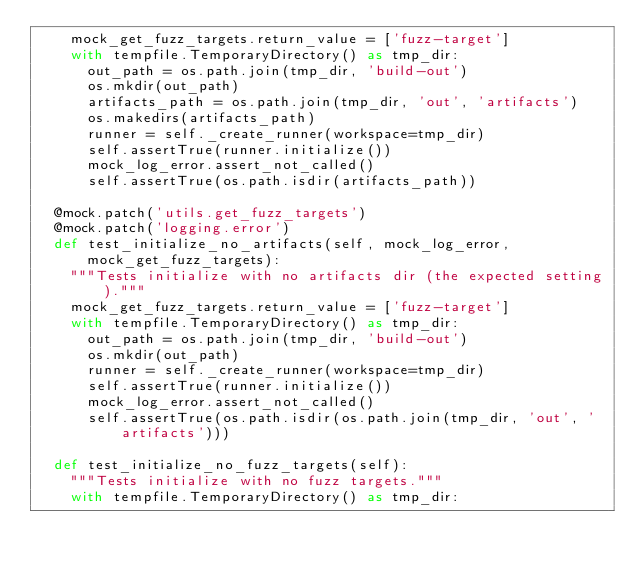Convert code to text. <code><loc_0><loc_0><loc_500><loc_500><_Python_>    mock_get_fuzz_targets.return_value = ['fuzz-target']
    with tempfile.TemporaryDirectory() as tmp_dir:
      out_path = os.path.join(tmp_dir, 'build-out')
      os.mkdir(out_path)
      artifacts_path = os.path.join(tmp_dir, 'out', 'artifacts')
      os.makedirs(artifacts_path)
      runner = self._create_runner(workspace=tmp_dir)
      self.assertTrue(runner.initialize())
      mock_log_error.assert_not_called()
      self.assertTrue(os.path.isdir(artifacts_path))

  @mock.patch('utils.get_fuzz_targets')
  @mock.patch('logging.error')
  def test_initialize_no_artifacts(self, mock_log_error, mock_get_fuzz_targets):
    """Tests initialize with no artifacts dir (the expected setting)."""
    mock_get_fuzz_targets.return_value = ['fuzz-target']
    with tempfile.TemporaryDirectory() as tmp_dir:
      out_path = os.path.join(tmp_dir, 'build-out')
      os.mkdir(out_path)
      runner = self._create_runner(workspace=tmp_dir)
      self.assertTrue(runner.initialize())
      mock_log_error.assert_not_called()
      self.assertTrue(os.path.isdir(os.path.join(tmp_dir, 'out', 'artifacts')))

  def test_initialize_no_fuzz_targets(self):
    """Tests initialize with no fuzz targets."""
    with tempfile.TemporaryDirectory() as tmp_dir:</code> 